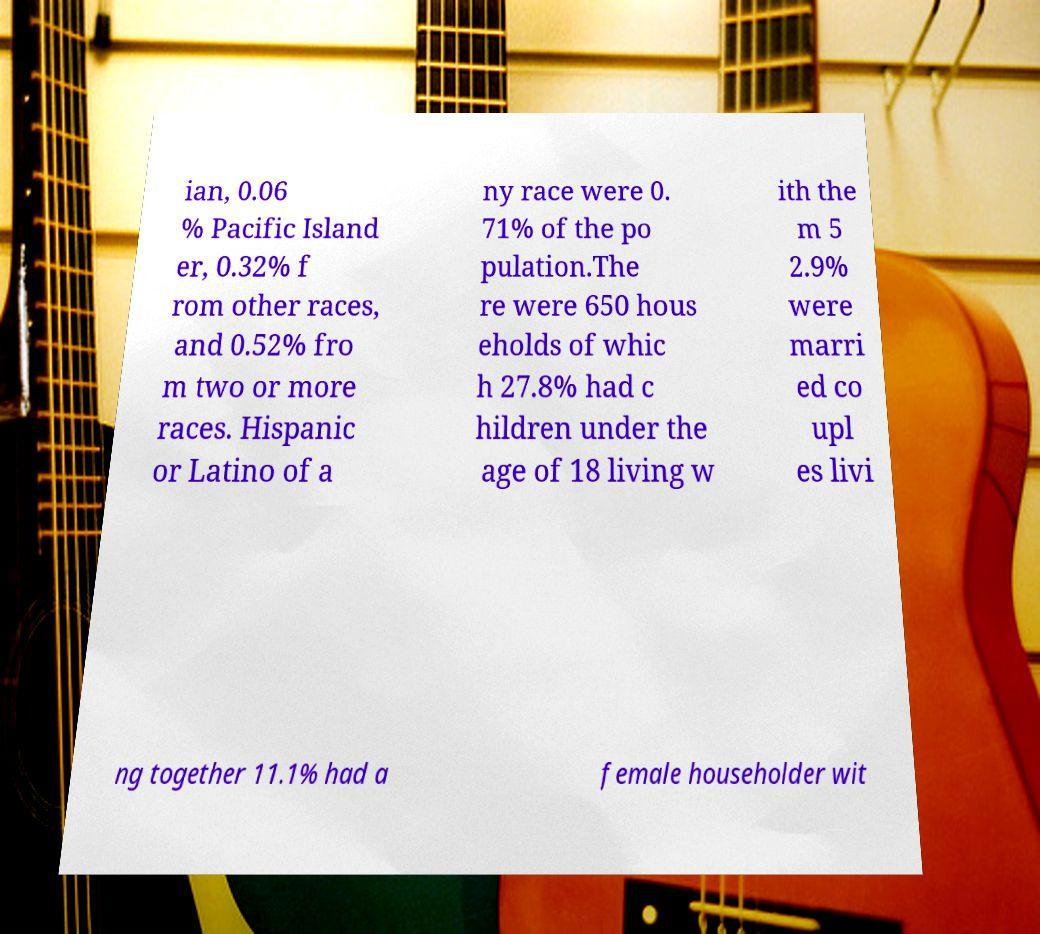Please identify and transcribe the text found in this image. ian, 0.06 % Pacific Island er, 0.32% f rom other races, and 0.52% fro m two or more races. Hispanic or Latino of a ny race were 0. 71% of the po pulation.The re were 650 hous eholds of whic h 27.8% had c hildren under the age of 18 living w ith the m 5 2.9% were marri ed co upl es livi ng together 11.1% had a female householder wit 